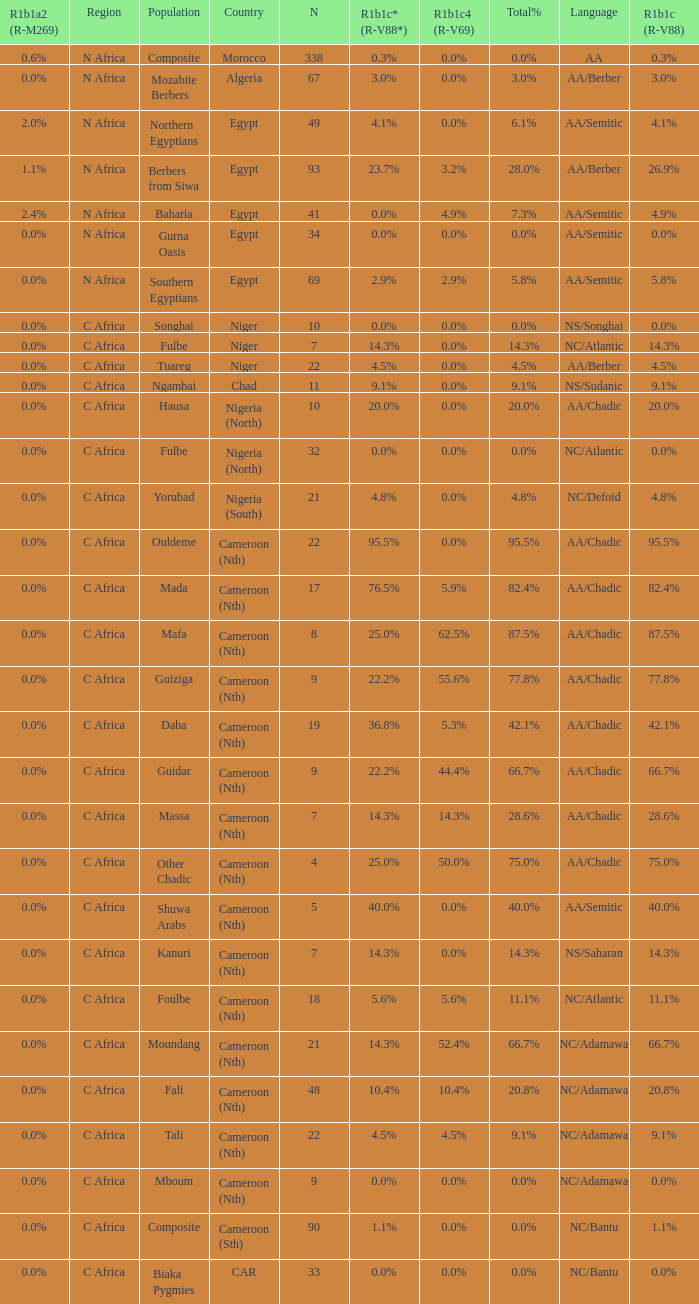0%? NS/Songhai. 